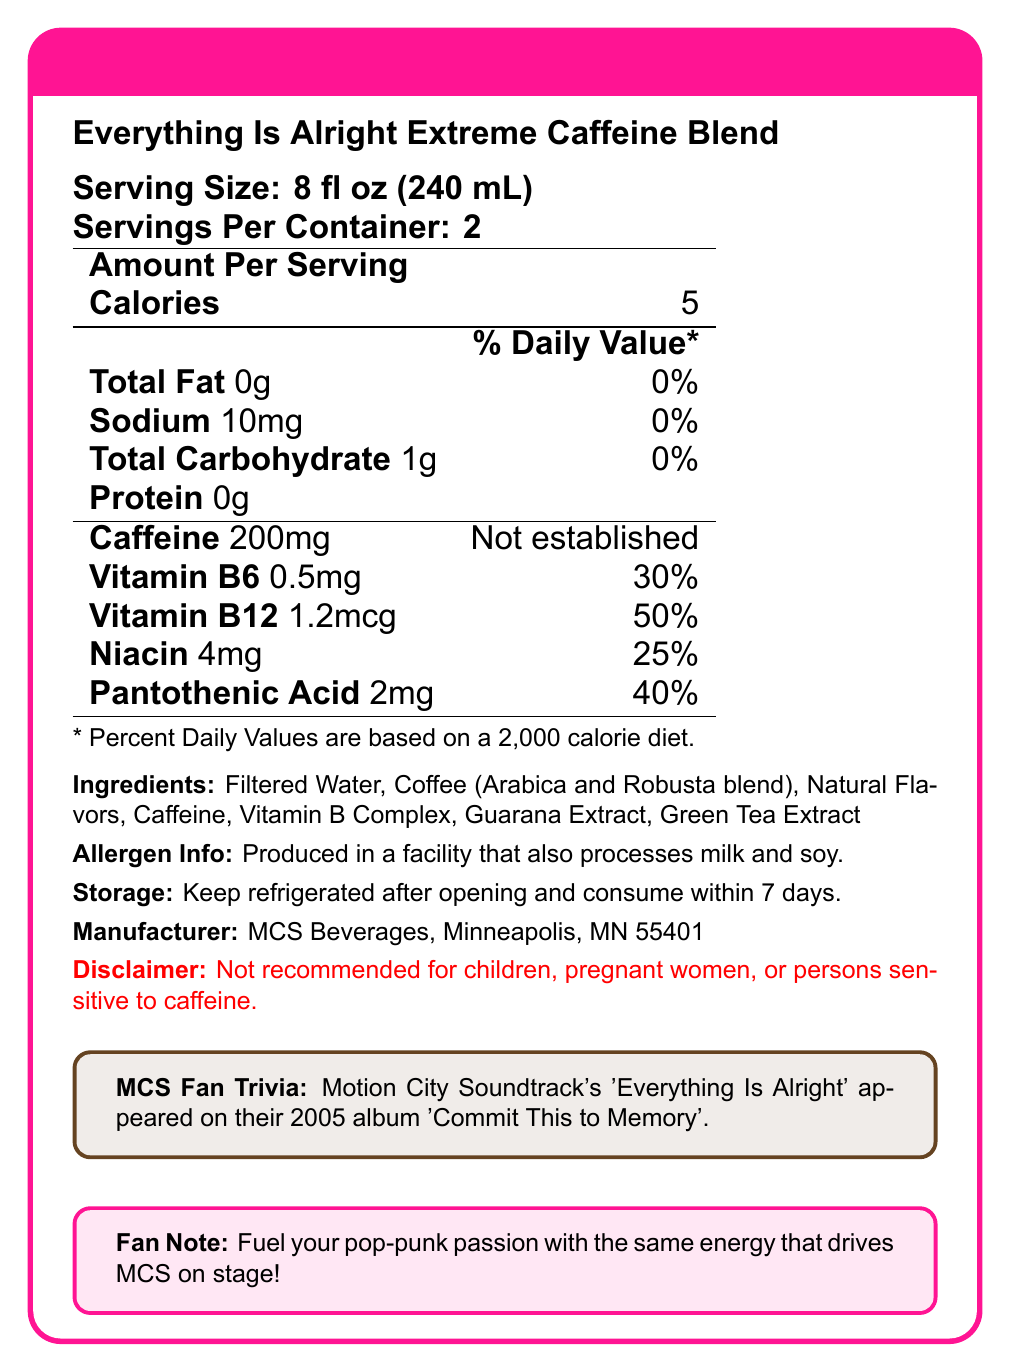what is the serving size? The serving size is explicitly stated under the product name "Everything Is Alright Extreme Caffeine Blend".
Answer: 8 fl oz (240 mL) how many servings are there per container? The number of servings per container is listed as "Servings Per Container: 2".
Answer: 2 what is the total number of calories per container? Each serving has 5 calories, and there are 2 servings per container, so 5 calories x 2 servings = 10 calories per container.
Answer: 10 what is the amount of Vitamin B6 per serving? The amount of Vitamin B6 is mentioned under "Amount Per Serving" as 0.5mg.
Answer: 0.5mg what is the daily value percentage of Vitamin B12 per serving? The daily value percentage of Vitamin B12 per serving is 50%, as indicated in the table.
Answer: 50% which ingredient is NOT present in the "Everything Is Alright Extreme Caffeine Blend"? A. Guarana Extract B. Sugar C. Green Tea Extract The ingredients list does not include sugar. It lists Filtered Water, Coffee, Natural Flavors, Caffeine, Vitamin B Complex, Guarana Extract, and Green Tea Extract.
Answer: B. Sugar where is the product manufactured? A. Chicago B. Minneapolis C. New York The document states that the manufacturer is "MCS Beverages, Minneapolis, MN 55401".
Answer: B. Minneapolis is this product recommended for children? The disclaimer in the document specifically states, "Not recommended for children, pregnant women, or persons sensitive to caffeine".
Answer: No describe the main idea of the document The document serves as a nutrition facts label, offering comprehensive information about the coffee product including nutritional content, ingredients, manufacturer details, and consumer advisories.
Answer: The document provides detailed nutrition information for "Everything Is Alright Extreme Caffeine Blend" coffee, including serving size, calorie content, vitamin content, and ingredients. It also includes allergen information, storage instructions, and a disclaimer. how much sodium is in the product per serving? The amount of sodium per serving is 10mg as stated in the nutrition facts.
Answer: 10mg what percentage of the daily value of pantothenic acid is in one serving? The percentage of the daily value of pantothenic acid per serving is mentioned as 40%.
Answer: 40% how much caffeine is in each serving of the coffee? The amount of caffeine per serving is stated to be 200mg.
Answer: 200mg what type of coffee blend is used in the product? The document lists the coffee blend as Arabica and Robusta.
Answer: Arabica and Robusta blend what album did Motion City Soundtrack's 'Everything Is Alright' appear on? The document mentions this trivia in the "MCS Fan Trivia" section.
Answer: Commit This to Memory can the exact caffeine daily value be determined from the document? The document states "Not established" for the caffeine daily value percentage, indicating that the exact value is not provided.
Answer: Cannot be determined how many grams of protein are in the "Everything Is Alright Extreme Caffeine Blend" per serving? The amount of protein per serving is listed as 0g in the nutrition facts.
Answer: 0g when should the product be consumed by after opening? The storage instructions specify to "Keep refrigerated after opening and consume within 7 days."
Answer: Within 7 days what is the total carbohydrate content per container? There is 1g of total carbohydrates per serving and 2 servings per container, so 1g x 2 = 2g in total per container.
Answer: 2g is the daily value percentage for sodium in the product higher than 0%? The daily value percentage for sodium is listed as 0%.
Answer: No what is required to store the product after opening? The document states, "Keep refrigerated after opening."
Answer: Refrigeration 